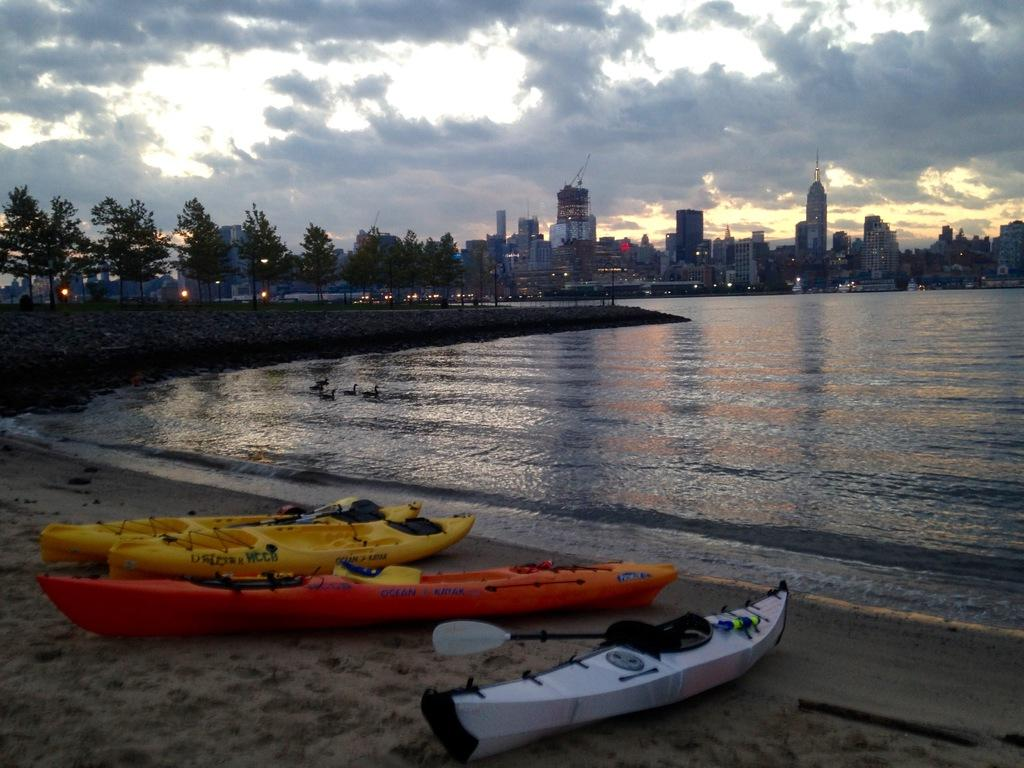What type of vehicles can be seen on the shore in the image? There are boats on the shore in the image. What animals are in the water in the image? There are ducks in the water in the image. What can be seen in the background of the image? There are trees, buildings, electric lights, and towers in the background of the image. What is visible in the sky in the image? The sky is visible in the background of the image, and clouds are present. How many pies are being balanced on the ducks' heads in the image? There are no pies present in the image, and the ducks are not balancing anything on their heads. 